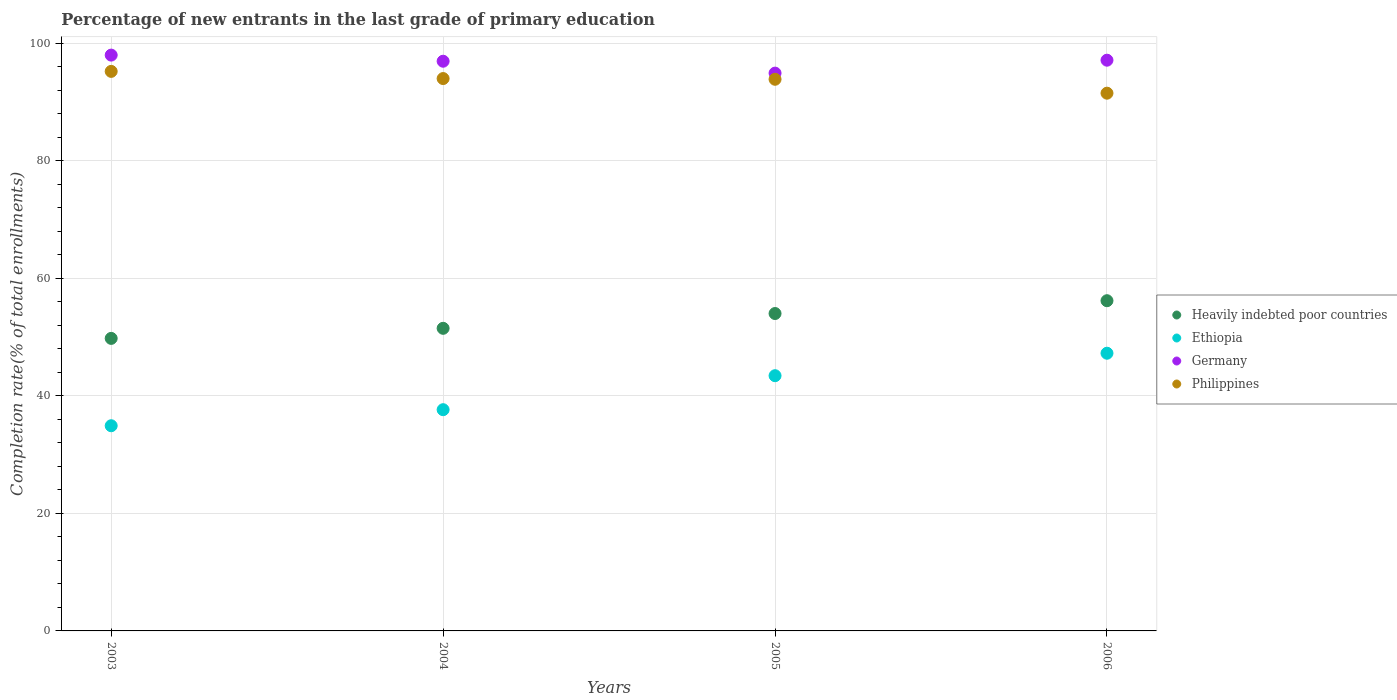Is the number of dotlines equal to the number of legend labels?
Give a very brief answer. Yes. What is the percentage of new entrants in Ethiopia in 2005?
Provide a short and direct response. 43.43. Across all years, what is the maximum percentage of new entrants in Heavily indebted poor countries?
Make the answer very short. 56.18. Across all years, what is the minimum percentage of new entrants in Philippines?
Provide a short and direct response. 91.49. In which year was the percentage of new entrants in Heavily indebted poor countries maximum?
Your response must be concise. 2006. What is the total percentage of new entrants in Philippines in the graph?
Ensure brevity in your answer.  374.53. What is the difference between the percentage of new entrants in Philippines in 2003 and that in 2005?
Your response must be concise. 1.34. What is the difference between the percentage of new entrants in Ethiopia in 2004 and the percentage of new entrants in Germany in 2003?
Your answer should be compact. -60.33. What is the average percentage of new entrants in Germany per year?
Offer a very short reply. 96.73. In the year 2006, what is the difference between the percentage of new entrants in Philippines and percentage of new entrants in Heavily indebted poor countries?
Your answer should be very brief. 35.31. What is the ratio of the percentage of new entrants in Heavily indebted poor countries in 2003 to that in 2006?
Ensure brevity in your answer.  0.89. Is the percentage of new entrants in Philippines in 2003 less than that in 2005?
Provide a succinct answer. No. What is the difference between the highest and the second highest percentage of new entrants in Ethiopia?
Give a very brief answer. 3.82. What is the difference between the highest and the lowest percentage of new entrants in Germany?
Offer a very short reply. 3.06. Does the percentage of new entrants in Philippines monotonically increase over the years?
Your answer should be very brief. No. Is the percentage of new entrants in Germany strictly greater than the percentage of new entrants in Ethiopia over the years?
Keep it short and to the point. Yes. How many dotlines are there?
Provide a short and direct response. 4. How many years are there in the graph?
Your response must be concise. 4. What is the difference between two consecutive major ticks on the Y-axis?
Your response must be concise. 20. Does the graph contain any zero values?
Keep it short and to the point. No. How are the legend labels stacked?
Provide a short and direct response. Vertical. What is the title of the graph?
Give a very brief answer. Percentage of new entrants in the last grade of primary education. What is the label or title of the Y-axis?
Offer a terse response. Completion rate(% of total enrollments). What is the Completion rate(% of total enrollments) in Heavily indebted poor countries in 2003?
Your response must be concise. 49.77. What is the Completion rate(% of total enrollments) in Ethiopia in 2003?
Your response must be concise. 34.91. What is the Completion rate(% of total enrollments) of Germany in 2003?
Make the answer very short. 97.97. What is the Completion rate(% of total enrollments) of Philippines in 2003?
Provide a short and direct response. 95.2. What is the Completion rate(% of total enrollments) of Heavily indebted poor countries in 2004?
Offer a terse response. 51.49. What is the Completion rate(% of total enrollments) in Ethiopia in 2004?
Make the answer very short. 37.64. What is the Completion rate(% of total enrollments) of Germany in 2004?
Provide a short and direct response. 96.93. What is the Completion rate(% of total enrollments) of Philippines in 2004?
Your answer should be very brief. 93.98. What is the Completion rate(% of total enrollments) of Heavily indebted poor countries in 2005?
Make the answer very short. 54. What is the Completion rate(% of total enrollments) of Ethiopia in 2005?
Make the answer very short. 43.43. What is the Completion rate(% of total enrollments) in Germany in 2005?
Your answer should be compact. 94.91. What is the Completion rate(% of total enrollments) of Philippines in 2005?
Keep it short and to the point. 93.86. What is the Completion rate(% of total enrollments) of Heavily indebted poor countries in 2006?
Keep it short and to the point. 56.18. What is the Completion rate(% of total enrollments) of Ethiopia in 2006?
Offer a very short reply. 47.25. What is the Completion rate(% of total enrollments) in Germany in 2006?
Give a very brief answer. 97.11. What is the Completion rate(% of total enrollments) of Philippines in 2006?
Ensure brevity in your answer.  91.49. Across all years, what is the maximum Completion rate(% of total enrollments) in Heavily indebted poor countries?
Offer a very short reply. 56.18. Across all years, what is the maximum Completion rate(% of total enrollments) of Ethiopia?
Make the answer very short. 47.25. Across all years, what is the maximum Completion rate(% of total enrollments) of Germany?
Ensure brevity in your answer.  97.97. Across all years, what is the maximum Completion rate(% of total enrollments) in Philippines?
Make the answer very short. 95.2. Across all years, what is the minimum Completion rate(% of total enrollments) in Heavily indebted poor countries?
Provide a succinct answer. 49.77. Across all years, what is the minimum Completion rate(% of total enrollments) of Ethiopia?
Your answer should be compact. 34.91. Across all years, what is the minimum Completion rate(% of total enrollments) in Germany?
Your answer should be very brief. 94.91. Across all years, what is the minimum Completion rate(% of total enrollments) of Philippines?
Make the answer very short. 91.49. What is the total Completion rate(% of total enrollments) of Heavily indebted poor countries in the graph?
Offer a terse response. 211.45. What is the total Completion rate(% of total enrollments) of Ethiopia in the graph?
Ensure brevity in your answer.  163.22. What is the total Completion rate(% of total enrollments) in Germany in the graph?
Provide a short and direct response. 386.92. What is the total Completion rate(% of total enrollments) in Philippines in the graph?
Keep it short and to the point. 374.53. What is the difference between the Completion rate(% of total enrollments) of Heavily indebted poor countries in 2003 and that in 2004?
Provide a short and direct response. -1.71. What is the difference between the Completion rate(% of total enrollments) in Ethiopia in 2003 and that in 2004?
Keep it short and to the point. -2.73. What is the difference between the Completion rate(% of total enrollments) of Germany in 2003 and that in 2004?
Provide a short and direct response. 1.04. What is the difference between the Completion rate(% of total enrollments) in Philippines in 2003 and that in 2004?
Make the answer very short. 1.22. What is the difference between the Completion rate(% of total enrollments) in Heavily indebted poor countries in 2003 and that in 2005?
Your answer should be compact. -4.23. What is the difference between the Completion rate(% of total enrollments) in Ethiopia in 2003 and that in 2005?
Your answer should be very brief. -8.52. What is the difference between the Completion rate(% of total enrollments) in Germany in 2003 and that in 2005?
Provide a succinct answer. 3.06. What is the difference between the Completion rate(% of total enrollments) of Philippines in 2003 and that in 2005?
Ensure brevity in your answer.  1.34. What is the difference between the Completion rate(% of total enrollments) of Heavily indebted poor countries in 2003 and that in 2006?
Your answer should be very brief. -6.41. What is the difference between the Completion rate(% of total enrollments) in Ethiopia in 2003 and that in 2006?
Keep it short and to the point. -12.34. What is the difference between the Completion rate(% of total enrollments) in Germany in 2003 and that in 2006?
Offer a terse response. 0.86. What is the difference between the Completion rate(% of total enrollments) in Philippines in 2003 and that in 2006?
Your answer should be compact. 3.71. What is the difference between the Completion rate(% of total enrollments) in Heavily indebted poor countries in 2004 and that in 2005?
Give a very brief answer. -2.52. What is the difference between the Completion rate(% of total enrollments) in Ethiopia in 2004 and that in 2005?
Make the answer very short. -5.78. What is the difference between the Completion rate(% of total enrollments) in Germany in 2004 and that in 2005?
Provide a short and direct response. 2.02. What is the difference between the Completion rate(% of total enrollments) in Philippines in 2004 and that in 2005?
Your response must be concise. 0.12. What is the difference between the Completion rate(% of total enrollments) in Heavily indebted poor countries in 2004 and that in 2006?
Ensure brevity in your answer.  -4.7. What is the difference between the Completion rate(% of total enrollments) of Ethiopia in 2004 and that in 2006?
Offer a very short reply. -9.61. What is the difference between the Completion rate(% of total enrollments) in Germany in 2004 and that in 2006?
Keep it short and to the point. -0.18. What is the difference between the Completion rate(% of total enrollments) of Philippines in 2004 and that in 2006?
Your response must be concise. 2.49. What is the difference between the Completion rate(% of total enrollments) of Heavily indebted poor countries in 2005 and that in 2006?
Give a very brief answer. -2.18. What is the difference between the Completion rate(% of total enrollments) in Ethiopia in 2005 and that in 2006?
Make the answer very short. -3.82. What is the difference between the Completion rate(% of total enrollments) of Germany in 2005 and that in 2006?
Provide a short and direct response. -2.2. What is the difference between the Completion rate(% of total enrollments) of Philippines in 2005 and that in 2006?
Keep it short and to the point. 2.37. What is the difference between the Completion rate(% of total enrollments) in Heavily indebted poor countries in 2003 and the Completion rate(% of total enrollments) in Ethiopia in 2004?
Provide a succinct answer. 12.13. What is the difference between the Completion rate(% of total enrollments) of Heavily indebted poor countries in 2003 and the Completion rate(% of total enrollments) of Germany in 2004?
Offer a terse response. -47.16. What is the difference between the Completion rate(% of total enrollments) of Heavily indebted poor countries in 2003 and the Completion rate(% of total enrollments) of Philippines in 2004?
Provide a succinct answer. -44.21. What is the difference between the Completion rate(% of total enrollments) of Ethiopia in 2003 and the Completion rate(% of total enrollments) of Germany in 2004?
Ensure brevity in your answer.  -62.02. What is the difference between the Completion rate(% of total enrollments) in Ethiopia in 2003 and the Completion rate(% of total enrollments) in Philippines in 2004?
Offer a terse response. -59.07. What is the difference between the Completion rate(% of total enrollments) in Germany in 2003 and the Completion rate(% of total enrollments) in Philippines in 2004?
Ensure brevity in your answer.  3.99. What is the difference between the Completion rate(% of total enrollments) of Heavily indebted poor countries in 2003 and the Completion rate(% of total enrollments) of Ethiopia in 2005?
Offer a very short reply. 6.35. What is the difference between the Completion rate(% of total enrollments) of Heavily indebted poor countries in 2003 and the Completion rate(% of total enrollments) of Germany in 2005?
Your response must be concise. -45.13. What is the difference between the Completion rate(% of total enrollments) in Heavily indebted poor countries in 2003 and the Completion rate(% of total enrollments) in Philippines in 2005?
Your answer should be compact. -44.09. What is the difference between the Completion rate(% of total enrollments) in Ethiopia in 2003 and the Completion rate(% of total enrollments) in Germany in 2005?
Provide a short and direct response. -60. What is the difference between the Completion rate(% of total enrollments) of Ethiopia in 2003 and the Completion rate(% of total enrollments) of Philippines in 2005?
Provide a succinct answer. -58.95. What is the difference between the Completion rate(% of total enrollments) of Germany in 2003 and the Completion rate(% of total enrollments) of Philippines in 2005?
Provide a short and direct response. 4.11. What is the difference between the Completion rate(% of total enrollments) of Heavily indebted poor countries in 2003 and the Completion rate(% of total enrollments) of Ethiopia in 2006?
Make the answer very short. 2.52. What is the difference between the Completion rate(% of total enrollments) of Heavily indebted poor countries in 2003 and the Completion rate(% of total enrollments) of Germany in 2006?
Make the answer very short. -47.33. What is the difference between the Completion rate(% of total enrollments) in Heavily indebted poor countries in 2003 and the Completion rate(% of total enrollments) in Philippines in 2006?
Offer a very short reply. -41.72. What is the difference between the Completion rate(% of total enrollments) in Ethiopia in 2003 and the Completion rate(% of total enrollments) in Germany in 2006?
Your answer should be compact. -62.2. What is the difference between the Completion rate(% of total enrollments) of Ethiopia in 2003 and the Completion rate(% of total enrollments) of Philippines in 2006?
Offer a terse response. -56.58. What is the difference between the Completion rate(% of total enrollments) of Germany in 2003 and the Completion rate(% of total enrollments) of Philippines in 2006?
Your answer should be very brief. 6.48. What is the difference between the Completion rate(% of total enrollments) of Heavily indebted poor countries in 2004 and the Completion rate(% of total enrollments) of Ethiopia in 2005?
Offer a very short reply. 8.06. What is the difference between the Completion rate(% of total enrollments) in Heavily indebted poor countries in 2004 and the Completion rate(% of total enrollments) in Germany in 2005?
Provide a succinct answer. -43.42. What is the difference between the Completion rate(% of total enrollments) of Heavily indebted poor countries in 2004 and the Completion rate(% of total enrollments) of Philippines in 2005?
Keep it short and to the point. -42.37. What is the difference between the Completion rate(% of total enrollments) of Ethiopia in 2004 and the Completion rate(% of total enrollments) of Germany in 2005?
Offer a very short reply. -57.27. What is the difference between the Completion rate(% of total enrollments) in Ethiopia in 2004 and the Completion rate(% of total enrollments) in Philippines in 2005?
Your answer should be very brief. -56.22. What is the difference between the Completion rate(% of total enrollments) in Germany in 2004 and the Completion rate(% of total enrollments) in Philippines in 2005?
Keep it short and to the point. 3.07. What is the difference between the Completion rate(% of total enrollments) in Heavily indebted poor countries in 2004 and the Completion rate(% of total enrollments) in Ethiopia in 2006?
Your response must be concise. 4.24. What is the difference between the Completion rate(% of total enrollments) of Heavily indebted poor countries in 2004 and the Completion rate(% of total enrollments) of Germany in 2006?
Keep it short and to the point. -45.62. What is the difference between the Completion rate(% of total enrollments) in Heavily indebted poor countries in 2004 and the Completion rate(% of total enrollments) in Philippines in 2006?
Your answer should be compact. -40.01. What is the difference between the Completion rate(% of total enrollments) of Ethiopia in 2004 and the Completion rate(% of total enrollments) of Germany in 2006?
Your answer should be very brief. -59.47. What is the difference between the Completion rate(% of total enrollments) of Ethiopia in 2004 and the Completion rate(% of total enrollments) of Philippines in 2006?
Make the answer very short. -53.85. What is the difference between the Completion rate(% of total enrollments) of Germany in 2004 and the Completion rate(% of total enrollments) of Philippines in 2006?
Keep it short and to the point. 5.44. What is the difference between the Completion rate(% of total enrollments) of Heavily indebted poor countries in 2005 and the Completion rate(% of total enrollments) of Ethiopia in 2006?
Offer a very short reply. 6.76. What is the difference between the Completion rate(% of total enrollments) of Heavily indebted poor countries in 2005 and the Completion rate(% of total enrollments) of Germany in 2006?
Your response must be concise. -43.1. What is the difference between the Completion rate(% of total enrollments) in Heavily indebted poor countries in 2005 and the Completion rate(% of total enrollments) in Philippines in 2006?
Offer a very short reply. -37.49. What is the difference between the Completion rate(% of total enrollments) in Ethiopia in 2005 and the Completion rate(% of total enrollments) in Germany in 2006?
Your answer should be very brief. -53.68. What is the difference between the Completion rate(% of total enrollments) of Ethiopia in 2005 and the Completion rate(% of total enrollments) of Philippines in 2006?
Provide a succinct answer. -48.07. What is the difference between the Completion rate(% of total enrollments) in Germany in 2005 and the Completion rate(% of total enrollments) in Philippines in 2006?
Keep it short and to the point. 3.41. What is the average Completion rate(% of total enrollments) in Heavily indebted poor countries per year?
Ensure brevity in your answer.  52.86. What is the average Completion rate(% of total enrollments) of Ethiopia per year?
Make the answer very short. 40.81. What is the average Completion rate(% of total enrollments) in Germany per year?
Ensure brevity in your answer.  96.73. What is the average Completion rate(% of total enrollments) in Philippines per year?
Your answer should be compact. 93.63. In the year 2003, what is the difference between the Completion rate(% of total enrollments) in Heavily indebted poor countries and Completion rate(% of total enrollments) in Ethiopia?
Offer a terse response. 14.86. In the year 2003, what is the difference between the Completion rate(% of total enrollments) of Heavily indebted poor countries and Completion rate(% of total enrollments) of Germany?
Offer a terse response. -48.2. In the year 2003, what is the difference between the Completion rate(% of total enrollments) of Heavily indebted poor countries and Completion rate(% of total enrollments) of Philippines?
Make the answer very short. -45.43. In the year 2003, what is the difference between the Completion rate(% of total enrollments) of Ethiopia and Completion rate(% of total enrollments) of Germany?
Provide a succinct answer. -63.06. In the year 2003, what is the difference between the Completion rate(% of total enrollments) of Ethiopia and Completion rate(% of total enrollments) of Philippines?
Provide a succinct answer. -60.29. In the year 2003, what is the difference between the Completion rate(% of total enrollments) of Germany and Completion rate(% of total enrollments) of Philippines?
Provide a short and direct response. 2.77. In the year 2004, what is the difference between the Completion rate(% of total enrollments) of Heavily indebted poor countries and Completion rate(% of total enrollments) of Ethiopia?
Offer a very short reply. 13.85. In the year 2004, what is the difference between the Completion rate(% of total enrollments) in Heavily indebted poor countries and Completion rate(% of total enrollments) in Germany?
Provide a succinct answer. -45.44. In the year 2004, what is the difference between the Completion rate(% of total enrollments) in Heavily indebted poor countries and Completion rate(% of total enrollments) in Philippines?
Give a very brief answer. -42.49. In the year 2004, what is the difference between the Completion rate(% of total enrollments) of Ethiopia and Completion rate(% of total enrollments) of Germany?
Provide a short and direct response. -59.29. In the year 2004, what is the difference between the Completion rate(% of total enrollments) of Ethiopia and Completion rate(% of total enrollments) of Philippines?
Make the answer very short. -56.34. In the year 2004, what is the difference between the Completion rate(% of total enrollments) of Germany and Completion rate(% of total enrollments) of Philippines?
Offer a very short reply. 2.95. In the year 2005, what is the difference between the Completion rate(% of total enrollments) of Heavily indebted poor countries and Completion rate(% of total enrollments) of Ethiopia?
Offer a very short reply. 10.58. In the year 2005, what is the difference between the Completion rate(% of total enrollments) of Heavily indebted poor countries and Completion rate(% of total enrollments) of Germany?
Your answer should be very brief. -40.9. In the year 2005, what is the difference between the Completion rate(% of total enrollments) in Heavily indebted poor countries and Completion rate(% of total enrollments) in Philippines?
Provide a short and direct response. -39.85. In the year 2005, what is the difference between the Completion rate(% of total enrollments) in Ethiopia and Completion rate(% of total enrollments) in Germany?
Offer a very short reply. -51.48. In the year 2005, what is the difference between the Completion rate(% of total enrollments) in Ethiopia and Completion rate(% of total enrollments) in Philippines?
Provide a short and direct response. -50.43. In the year 2005, what is the difference between the Completion rate(% of total enrollments) of Germany and Completion rate(% of total enrollments) of Philippines?
Make the answer very short. 1.05. In the year 2006, what is the difference between the Completion rate(% of total enrollments) of Heavily indebted poor countries and Completion rate(% of total enrollments) of Ethiopia?
Provide a succinct answer. 8.94. In the year 2006, what is the difference between the Completion rate(% of total enrollments) of Heavily indebted poor countries and Completion rate(% of total enrollments) of Germany?
Offer a very short reply. -40.92. In the year 2006, what is the difference between the Completion rate(% of total enrollments) in Heavily indebted poor countries and Completion rate(% of total enrollments) in Philippines?
Make the answer very short. -35.31. In the year 2006, what is the difference between the Completion rate(% of total enrollments) in Ethiopia and Completion rate(% of total enrollments) in Germany?
Keep it short and to the point. -49.86. In the year 2006, what is the difference between the Completion rate(% of total enrollments) of Ethiopia and Completion rate(% of total enrollments) of Philippines?
Give a very brief answer. -44.25. In the year 2006, what is the difference between the Completion rate(% of total enrollments) of Germany and Completion rate(% of total enrollments) of Philippines?
Offer a terse response. 5.61. What is the ratio of the Completion rate(% of total enrollments) in Heavily indebted poor countries in 2003 to that in 2004?
Ensure brevity in your answer.  0.97. What is the ratio of the Completion rate(% of total enrollments) of Ethiopia in 2003 to that in 2004?
Make the answer very short. 0.93. What is the ratio of the Completion rate(% of total enrollments) in Germany in 2003 to that in 2004?
Offer a terse response. 1.01. What is the ratio of the Completion rate(% of total enrollments) of Philippines in 2003 to that in 2004?
Offer a terse response. 1.01. What is the ratio of the Completion rate(% of total enrollments) in Heavily indebted poor countries in 2003 to that in 2005?
Your answer should be very brief. 0.92. What is the ratio of the Completion rate(% of total enrollments) of Ethiopia in 2003 to that in 2005?
Your response must be concise. 0.8. What is the ratio of the Completion rate(% of total enrollments) in Germany in 2003 to that in 2005?
Provide a short and direct response. 1.03. What is the ratio of the Completion rate(% of total enrollments) of Philippines in 2003 to that in 2005?
Offer a terse response. 1.01. What is the ratio of the Completion rate(% of total enrollments) in Heavily indebted poor countries in 2003 to that in 2006?
Keep it short and to the point. 0.89. What is the ratio of the Completion rate(% of total enrollments) in Ethiopia in 2003 to that in 2006?
Keep it short and to the point. 0.74. What is the ratio of the Completion rate(% of total enrollments) in Germany in 2003 to that in 2006?
Your answer should be compact. 1.01. What is the ratio of the Completion rate(% of total enrollments) of Philippines in 2003 to that in 2006?
Provide a succinct answer. 1.04. What is the ratio of the Completion rate(% of total enrollments) of Heavily indebted poor countries in 2004 to that in 2005?
Ensure brevity in your answer.  0.95. What is the ratio of the Completion rate(% of total enrollments) of Ethiopia in 2004 to that in 2005?
Your answer should be compact. 0.87. What is the ratio of the Completion rate(% of total enrollments) of Germany in 2004 to that in 2005?
Make the answer very short. 1.02. What is the ratio of the Completion rate(% of total enrollments) of Heavily indebted poor countries in 2004 to that in 2006?
Provide a short and direct response. 0.92. What is the ratio of the Completion rate(% of total enrollments) of Ethiopia in 2004 to that in 2006?
Keep it short and to the point. 0.8. What is the ratio of the Completion rate(% of total enrollments) in Germany in 2004 to that in 2006?
Offer a terse response. 1. What is the ratio of the Completion rate(% of total enrollments) of Philippines in 2004 to that in 2006?
Ensure brevity in your answer.  1.03. What is the ratio of the Completion rate(% of total enrollments) of Heavily indebted poor countries in 2005 to that in 2006?
Your answer should be very brief. 0.96. What is the ratio of the Completion rate(% of total enrollments) of Ethiopia in 2005 to that in 2006?
Your answer should be compact. 0.92. What is the ratio of the Completion rate(% of total enrollments) of Germany in 2005 to that in 2006?
Your response must be concise. 0.98. What is the ratio of the Completion rate(% of total enrollments) of Philippines in 2005 to that in 2006?
Your response must be concise. 1.03. What is the difference between the highest and the second highest Completion rate(% of total enrollments) in Heavily indebted poor countries?
Ensure brevity in your answer.  2.18. What is the difference between the highest and the second highest Completion rate(% of total enrollments) in Ethiopia?
Offer a very short reply. 3.82. What is the difference between the highest and the second highest Completion rate(% of total enrollments) of Germany?
Offer a terse response. 0.86. What is the difference between the highest and the second highest Completion rate(% of total enrollments) in Philippines?
Your answer should be compact. 1.22. What is the difference between the highest and the lowest Completion rate(% of total enrollments) in Heavily indebted poor countries?
Offer a very short reply. 6.41. What is the difference between the highest and the lowest Completion rate(% of total enrollments) of Ethiopia?
Give a very brief answer. 12.34. What is the difference between the highest and the lowest Completion rate(% of total enrollments) in Germany?
Your answer should be compact. 3.06. What is the difference between the highest and the lowest Completion rate(% of total enrollments) in Philippines?
Keep it short and to the point. 3.71. 